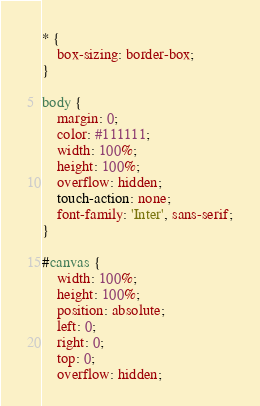<code> <loc_0><loc_0><loc_500><loc_500><_CSS_>* {
    box-sizing: border-box;
}

body {
    margin: 0;
    color: #111111;
    width: 100%;
    height: 100%;
    overflow: hidden;
    touch-action: none;
    font-family: 'Inter', sans-serif;
}

#canvas {
    width: 100%;
    height: 100%;
    position: absolute;
    left: 0;
    right: 0;
    top: 0;
    overflow: hidden;</code> 